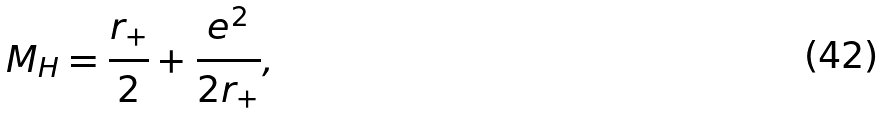<formula> <loc_0><loc_0><loc_500><loc_500>M _ { H } = \frac { r _ { + } } { 2 } + \frac { e ^ { 2 } } { 2 r _ { + } } ,</formula> 